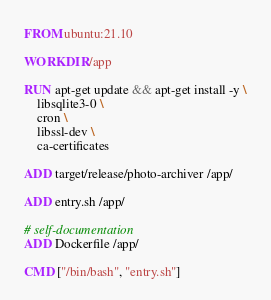Convert code to text. <code><loc_0><loc_0><loc_500><loc_500><_Dockerfile_>FROM ubuntu:21.10

WORKDIR /app

RUN apt-get update && apt-get install -y \
    libsqlite3-0 \
    cron \
    libssl-dev \
    ca-certificates

ADD target/release/photo-archiver /app/

ADD entry.sh /app/

# self-documentation
ADD Dockerfile /app/

CMD ["/bin/bash", "entry.sh"]
</code> 